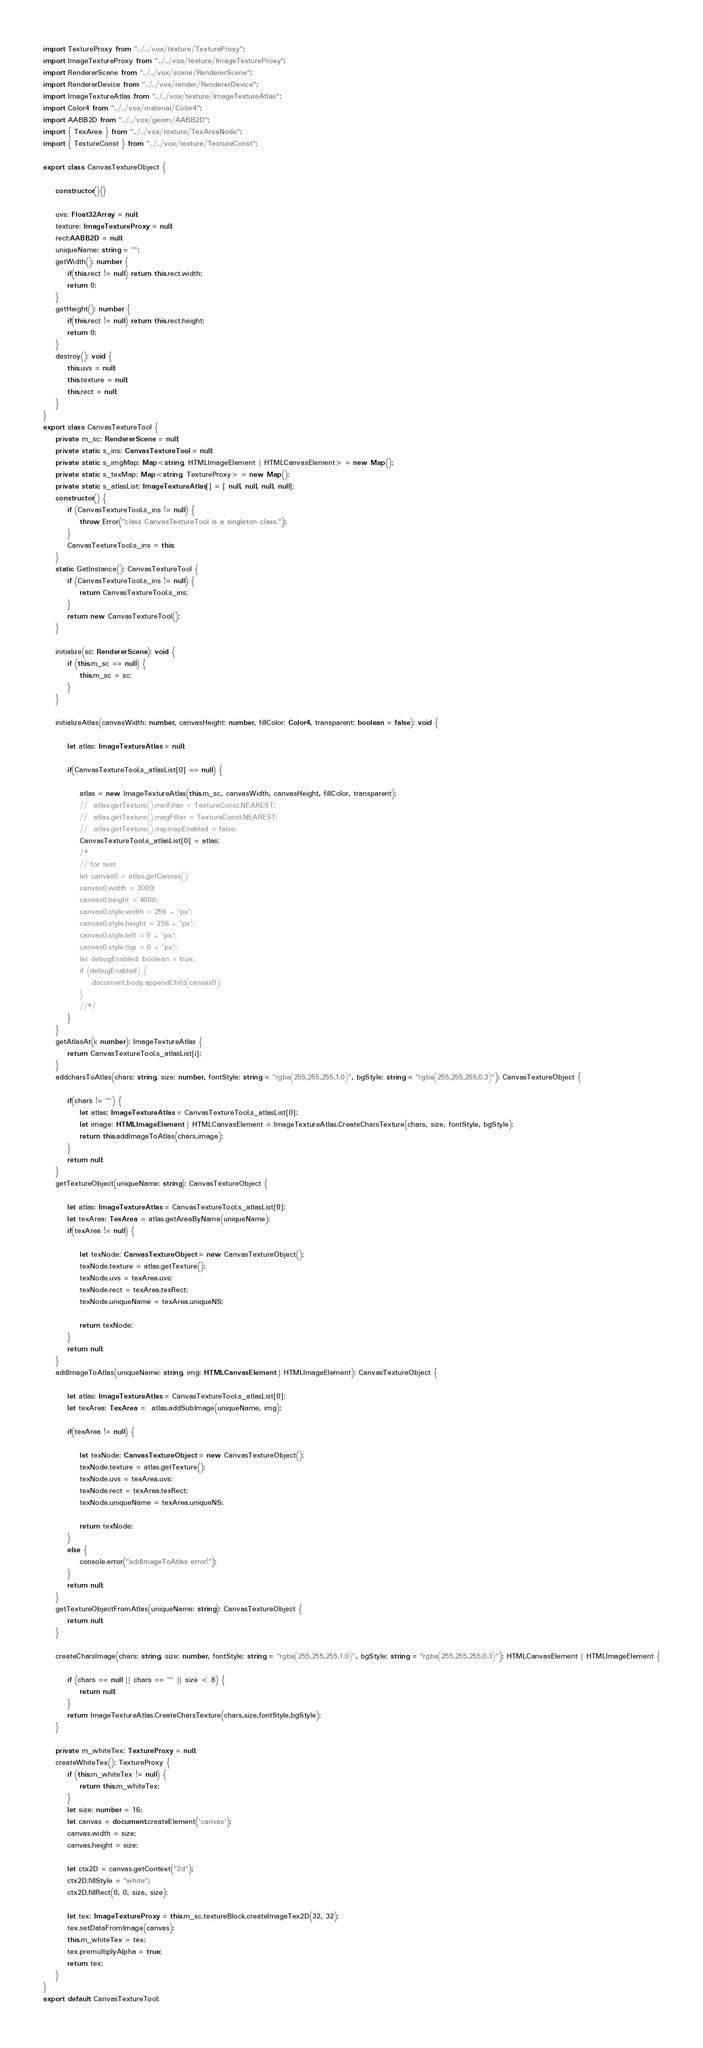Convert code to text. <code><loc_0><loc_0><loc_500><loc_500><_TypeScript_>
import TextureProxy from "../../vox/texture/TextureProxy";
import ImageTextureProxy from "../../vox/texture/ImageTextureProxy";
import RendererScene from "../../vox/scene/RendererScene";
import RendererDevice from "../../vox/render/RendererDevice";
import ImageTextureAtlas from "../../vox/texture/ImageTextureAtlas";
import Color4 from "../../vox/material/Color4";
import AABB2D from "../../vox/geom/AABB2D";
import { TexArea } from "../../vox/texture/TexAreaNode";
import { TextureConst } from "../../vox/texture/TextureConst";

export class CanvasTextureObject {

    constructor(){}

    uvs: Float32Array = null;
    texture: ImageTextureProxy = null;
    rect:AABB2D = null;
    uniqueName: string = "";
    getWidth(): number {
        if(this.rect != null) return this.rect.width;
        return 0;
    }
    getHeight(): number {
        if(this.rect != null) return this.rect.height;
        return 0;
    }
    destroy(): void {
        this.uvs = null;
        this.texture = null;
        this.rect = null;
    }
}
export class CanvasTextureTool {
    private m_sc: RendererScene = null;
    private static s_ins: CanvasTextureTool = null;
    private static s_imgMap: Map<string, HTMLImageElement | HTMLCanvasElement> = new Map();
    private static s_texMap: Map<string, TextureProxy> = new Map();
    private static s_atlasList: ImageTextureAtlas[] = [ null, null, null, null];
    constructor() {
        if (CanvasTextureTool.s_ins != null) {
            throw Error("class CanvasTextureTool is a singleton class.");
        }
        CanvasTextureTool.s_ins = this;
    }
    static GetInstance(): CanvasTextureTool {
        if (CanvasTextureTool.s_ins != null) {
            return CanvasTextureTool.s_ins;
        }
        return new CanvasTextureTool();
    }

    initialize(sc: RendererScene): void {
        if (this.m_sc == null) {
            this.m_sc = sc;
        }
    }

    initializeAtlas(canvasWidth: number, canvasHeight: number, fillColor: Color4, transparent: boolean = false): void {
        
        let atlas: ImageTextureAtlas = null;

        if(CanvasTextureTool.s_atlasList[0] == null) {

            atlas = new ImageTextureAtlas(this.m_sc, canvasWidth, canvasHeight, fillColor, transparent);
            //  atlas.getTexture().minFilter = TextureConst.NEAREST;
            //  atlas.getTexture().magFilter = TextureConst.NEAREST;
            //  atlas.getTexture().mipmapEnabled = false;
            CanvasTextureTool.s_atlasList[0] = atlas;
            /*
            // for test
            let canvas0 = atlas.getCanvas();
            canvas0.width = 3000;
            canvas0.height = 4000;
            canvas0.style.width = 256 + 'px';
            canvas0.style.height = 256 + 'px';
            canvas0.style.left = 0 + 'px';
            canvas0.style.top = 0 + 'px';
            let debugEnabled: boolean = true;
            if (debugEnabled) {
                document.body.appendChild(canvas0);
            }
            //*/
        }
    }
    getAtlasAt(i: number): ImageTextureAtlas {
        return CanvasTextureTool.s_atlasList[i];
    }
    addcharsToAtlas(chars: string, size: number, fontStyle: string = "rgba(255,255,255,1.0)", bgStyle: string = "rgba(255,255,255,0.3)"): CanvasTextureObject {
        
        if(chars != "") {
            let atlas: ImageTextureAtlas = CanvasTextureTool.s_atlasList[0];
            let image: HTMLImageElement | HTMLCanvasElement = ImageTextureAtlas.CreateCharsTexture(chars, size, fontStyle, bgStyle);
            return this.addImageToAtlas(chars,image);
        }
        return null;
    }
    getTextureObject(uniqueName: string): CanvasTextureObject {

        let atlas: ImageTextureAtlas = CanvasTextureTool.s_atlasList[0];
        let texArea: TexArea = atlas.getAreaByName(uniqueName);
        if(texArea != null) {

            let texNode: CanvasTextureObject = new CanvasTextureObject();
            texNode.texture = atlas.getTexture();
            texNode.uvs = texArea.uvs;
            texNode.rect = texArea.texRect;
            texNode.uniqueName = texArea.uniqueNS;
            
            return texNode;
        }
        return null;
    }
    addImageToAtlas(uniqueName: string, img: HTMLCanvasElement | HTMLImageElement): CanvasTextureObject {

        let atlas: ImageTextureAtlas = CanvasTextureTool.s_atlasList[0];
        let texArea: TexArea =  atlas.addSubImage(uniqueName, img);

        if(texArea != null) {

            let texNode: CanvasTextureObject = new CanvasTextureObject();
            texNode.texture = atlas.getTexture();
            texNode.uvs = texArea.uvs;
            texNode.rect = texArea.texRect;
            texNode.uniqueName = texArea.uniqueNS;
            
            return texNode;
        }
        else {
            console.error("addImageToAtlas error!");
        }
        return null;
    }
    getTextureObjectFromAtlas(uniqueName: string): CanvasTextureObject {
        return null;
    }

    createCharsImage(chars: string, size: number, fontStyle: string = "rgba(255,255,255,1.0)", bgStyle: string = "rgba(255,255,255,0.3)"): HTMLCanvasElement | HTMLImageElement {
        
        if (chars == null || chars == "" || size < 8) {
            return null;
        }
        return ImageTextureAtlas.CreateCharsTexture(chars,size,fontStyle,bgStyle);
    }
    
    private m_whiteTex: TextureProxy = null;
    createWhiteTex(): TextureProxy {
        if (this.m_whiteTex != null) {
            return this.m_whiteTex;
        }
        let size: number = 16;
        let canvas = document.createElement('canvas');
        canvas.width = size;
        canvas.height = size;

        let ctx2D = canvas.getContext("2d");
        ctx2D.fillStyle = "white";
        ctx2D.fillRect(0, 0, size, size);

        let tex: ImageTextureProxy = this.m_sc.textureBlock.createImageTex2D(32, 32);
        tex.setDataFromImage(canvas);
        this.m_whiteTex = tex;
        tex.premultiplyAlpha = true;
        return tex;
    }
}
export default CanvasTextureTool;</code> 